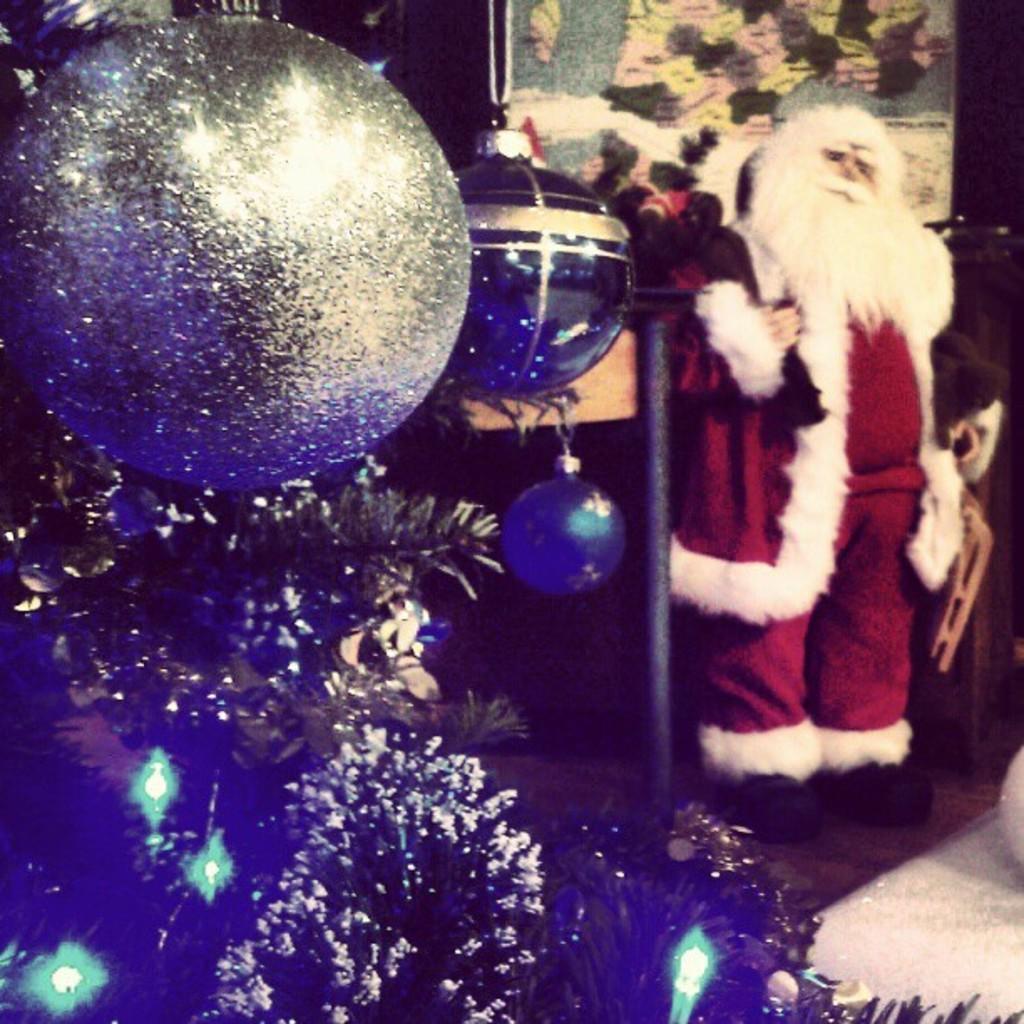How would you summarize this image in a sentence or two? In the image in the center, we can see one doll, which is in red and white costume. And we can see one Christmas tree and few decorative items. 